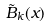Convert formula to latex. <formula><loc_0><loc_0><loc_500><loc_500>\tilde { B } _ { k } ( x )</formula> 